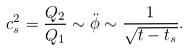Convert formula to latex. <formula><loc_0><loc_0><loc_500><loc_500>c _ { s } ^ { 2 } = \frac { Q _ { 2 } } { Q _ { 1 } } \sim \ddot { \phi } \sim \frac { 1 } { \sqrt { t - t _ { s } } } .</formula> 